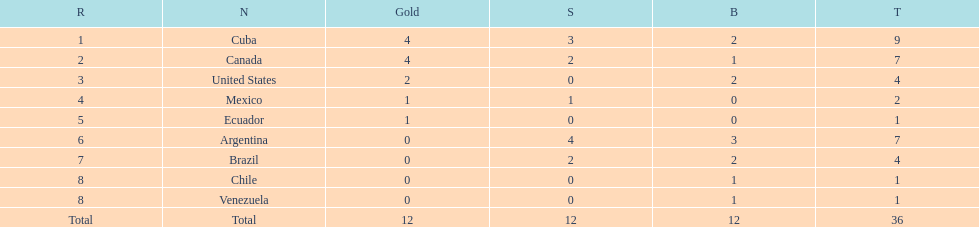In which nation did they achieve the gold medal without winning silver? United States. 